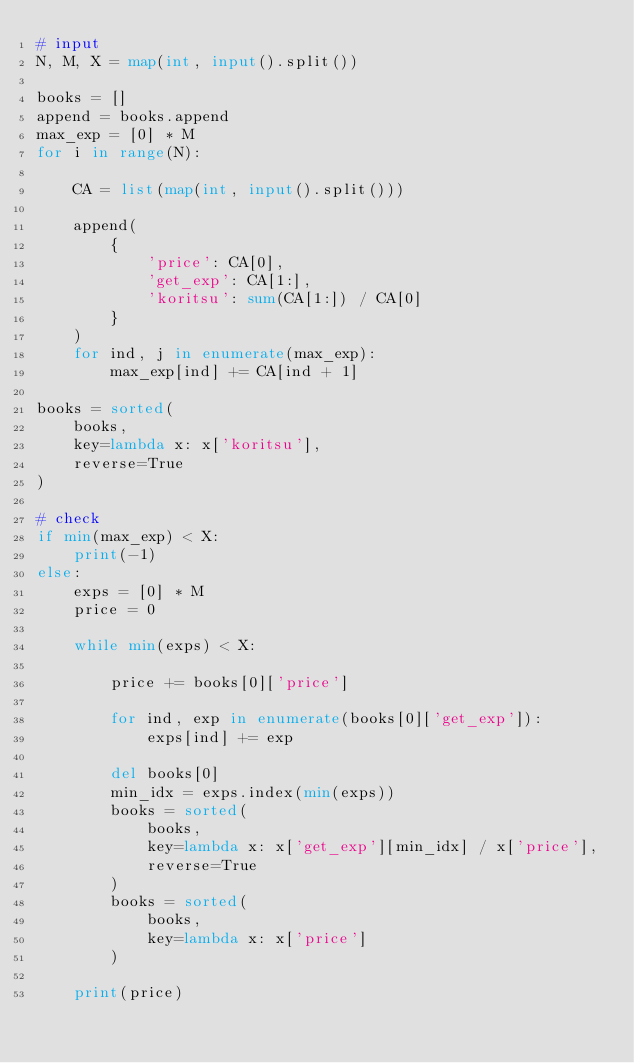<code> <loc_0><loc_0><loc_500><loc_500><_Python_># input
N, M, X = map(int, input().split())

books = []
append = books.append
max_exp = [0] * M
for i in range(N):

    CA = list(map(int, input().split()))

    append(
        {
            'price': CA[0],
            'get_exp': CA[1:],
            'koritsu': sum(CA[1:]) / CA[0]
        }
    )
    for ind, j in enumerate(max_exp):
        max_exp[ind] += CA[ind + 1]

books = sorted(
    books,
    key=lambda x: x['koritsu'],
    reverse=True
)

# check
if min(max_exp) < X:
    print(-1)
else:
    exps = [0] * M
    price = 0

    while min(exps) < X:

        price += books[0]['price']

        for ind, exp in enumerate(books[0]['get_exp']):
            exps[ind] += exp

        del books[0]
        min_idx = exps.index(min(exps))
        books = sorted(
            books,
            key=lambda x: x['get_exp'][min_idx] / x['price'],
            reverse=True
        )
        books = sorted(
            books,
            key=lambda x: x['price']
        )

    print(price)
</code> 